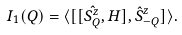<formula> <loc_0><loc_0><loc_500><loc_500>I _ { 1 } ( Q ) = \langle [ [ \hat { S _ { Q } ^ { z } } , H ] , \hat { S } _ { - Q } ^ { z } ] \rangle .</formula> 